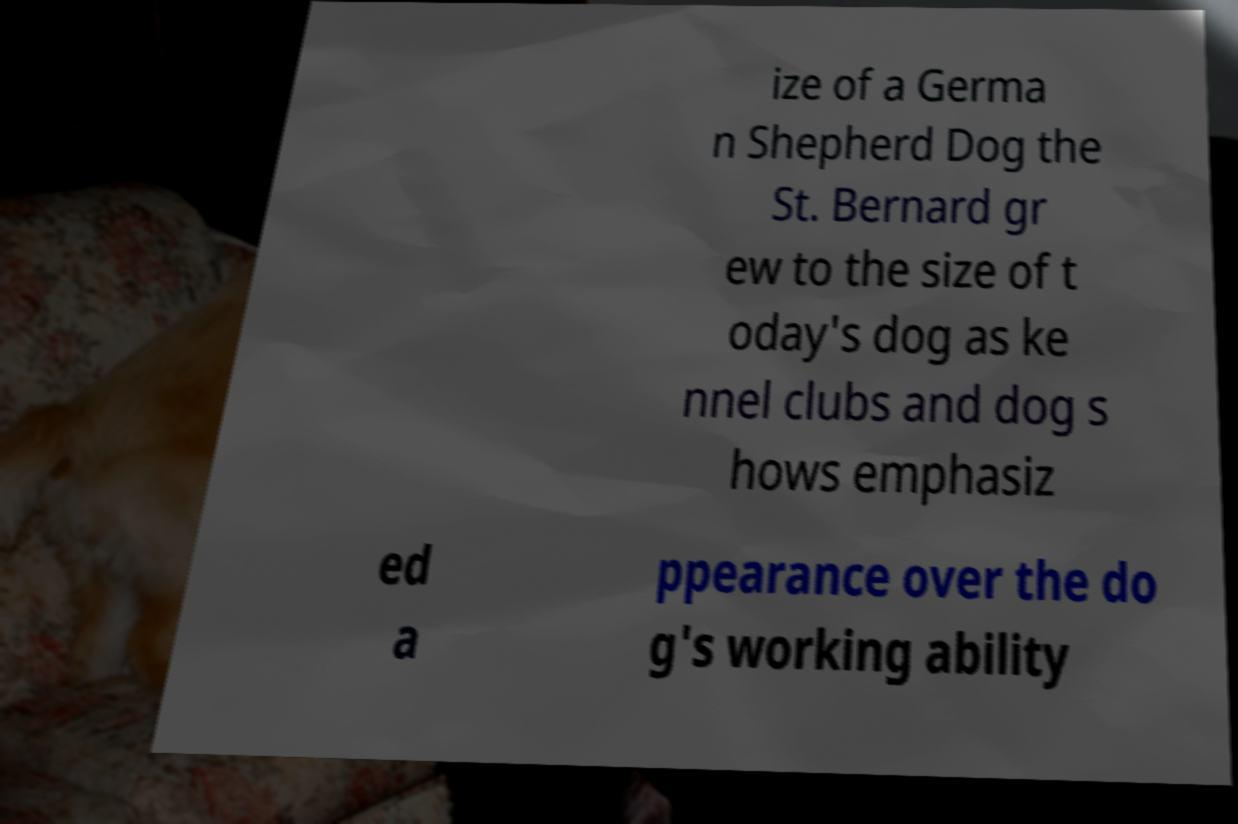I need the written content from this picture converted into text. Can you do that? ize of a Germa n Shepherd Dog the St. Bernard gr ew to the size of t oday's dog as ke nnel clubs and dog s hows emphasiz ed a ppearance over the do g's working ability 